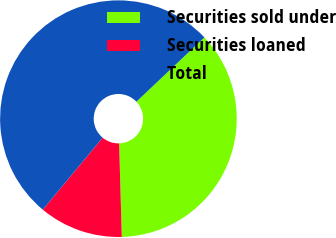<chart> <loc_0><loc_0><loc_500><loc_500><pie_chart><fcel>Securities sold under<fcel>Securities loaned<fcel>Total<nl><fcel>36.6%<fcel>11.49%<fcel>51.91%<nl></chart> 